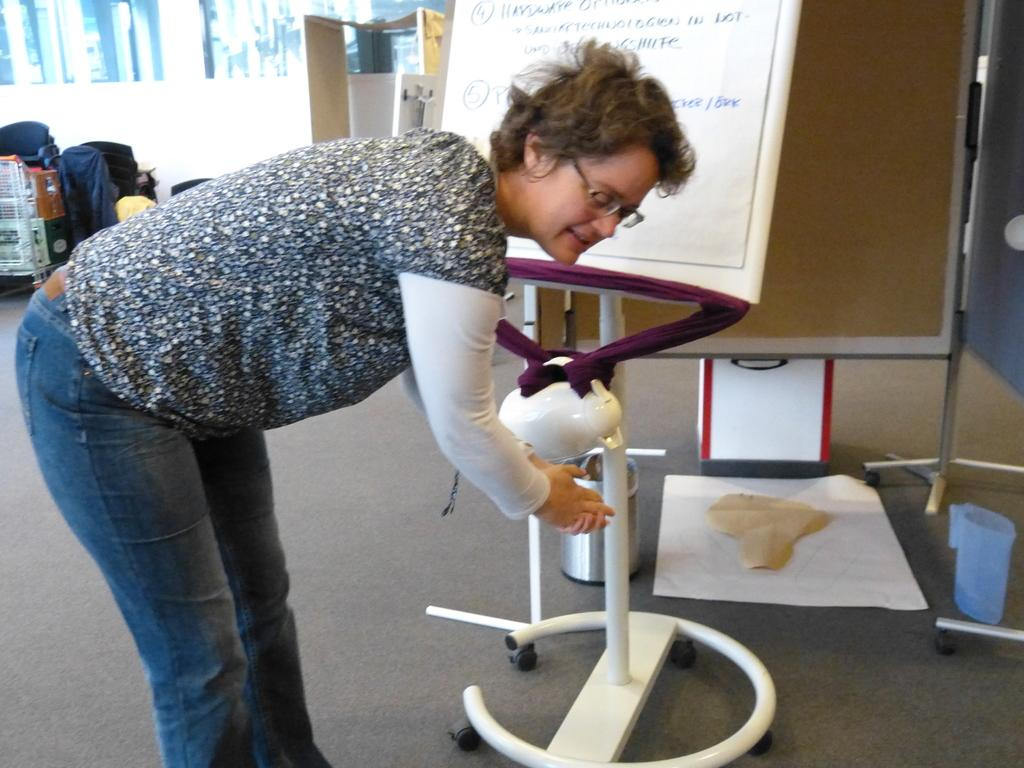What is the main subject of the image? There is a person standing in the image. What objects are visible in the image besides the person? There are papers, boards, a jug, and chairs visible in the image. Can you describe the background of the image? There are other items visible in the background of the image, including chairs. What time of day is it in the image, based on the hour shown on the desk clock? There is no desk clock present in the image, so it is not possible to determine the time of day. 